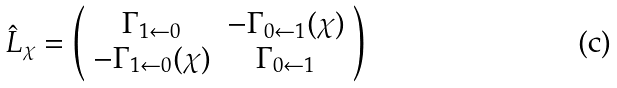Convert formula to latex. <formula><loc_0><loc_0><loc_500><loc_500>\hat { L } _ { \chi } = \left ( \begin{array} { c c } \Gamma _ { 1 \leftarrow 0 } & - \Gamma _ { 0 \leftarrow 1 } ( \chi ) \\ - \Gamma _ { 1 \leftarrow 0 } ( \chi ) & \Gamma _ { 0 \leftarrow 1 } \end{array} \right )</formula> 